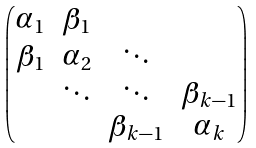<formula> <loc_0><loc_0><loc_500><loc_500>\begin{pmatrix} \alpha _ { 1 } & \beta _ { 1 } & & \\ \beta _ { 1 } & \alpha _ { 2 } & \ddots & \\ & \ddots & \ddots & \beta _ { k - 1 } \\ & & \beta _ { k - 1 } & \alpha _ { k } \\ \end{pmatrix}</formula> 